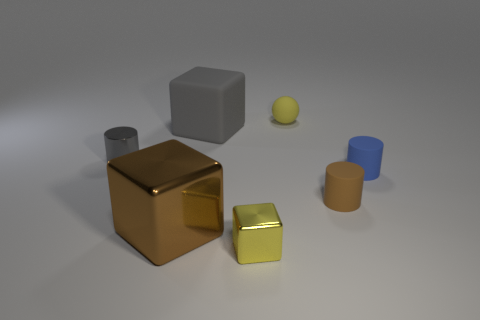Are there any other things that have the same material as the blue thing?
Your response must be concise. Yes. Is the number of tiny gray shiny cylinders that are to the right of the blue thing the same as the number of gray matte objects that are to the right of the brown rubber cylinder?
Your response must be concise. Yes. Does the tiny gray cylinder have the same material as the small blue object?
Your answer should be very brief. No. How many cyan things are small matte balls or large metal cubes?
Keep it short and to the point. 0. How many large brown things have the same shape as the tiny blue rubber thing?
Your answer should be very brief. 0. What is the brown cylinder made of?
Make the answer very short. Rubber. Are there an equal number of tiny yellow matte things in front of the small gray shiny thing and small blue blocks?
Offer a very short reply. Yes. The other thing that is the same size as the gray matte object is what shape?
Make the answer very short. Cube. Is there a yellow sphere that is on the left side of the block that is behind the blue cylinder?
Ensure brevity in your answer.  No. How many large things are either cyan spheres or yellow metallic objects?
Offer a very short reply. 0. 